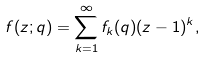<formula> <loc_0><loc_0><loc_500><loc_500>f ( z ; q ) = \sum _ { k = 1 } ^ { \infty } f _ { k } ( q ) ( z - 1 ) ^ { k } ,</formula> 